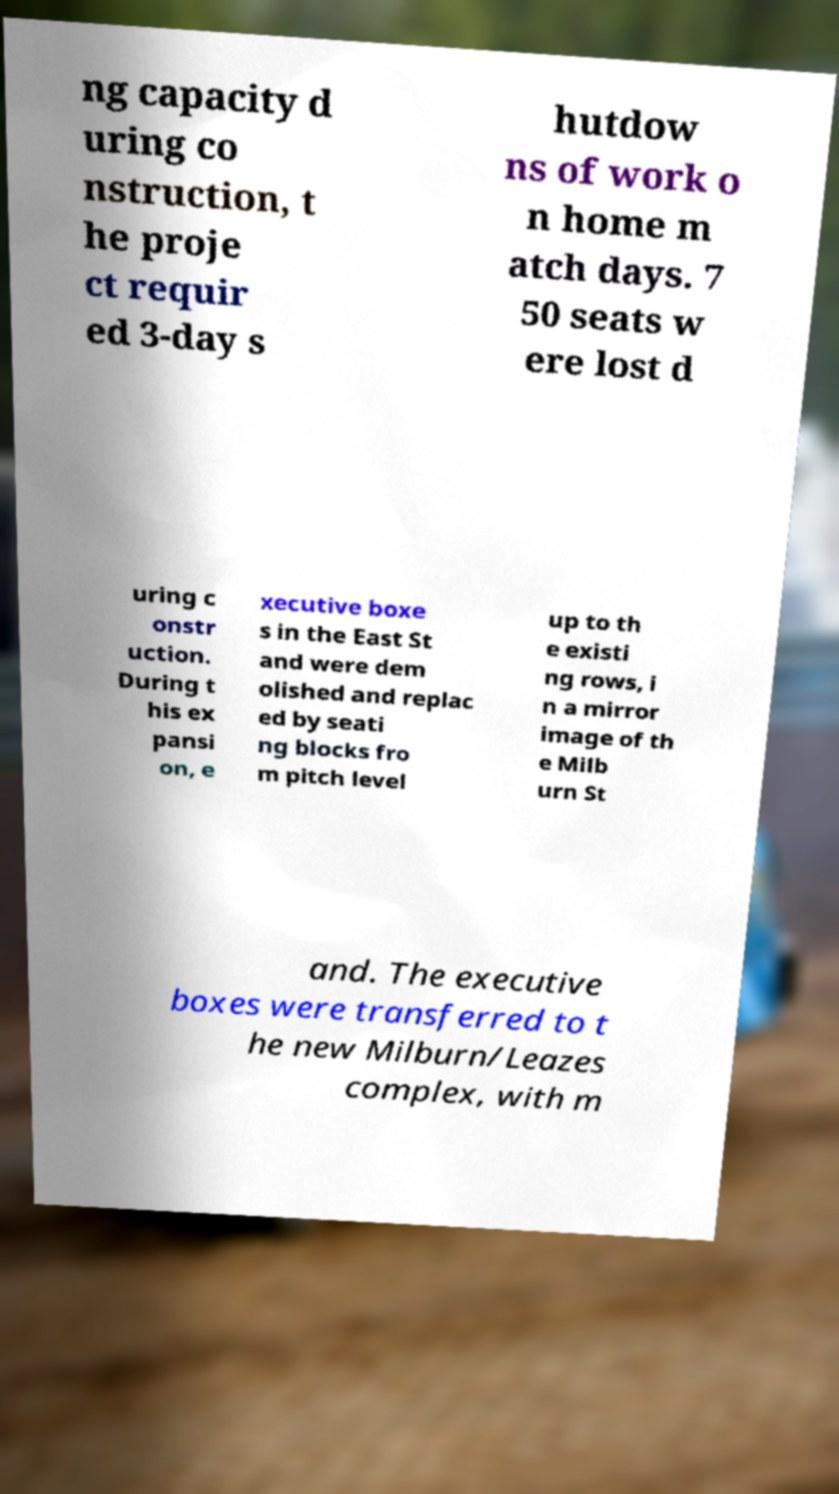Please read and relay the text visible in this image. What does it say? ng capacity d uring co nstruction, t he proje ct requir ed 3-day s hutdow ns of work o n home m atch days. 7 50 seats w ere lost d uring c onstr uction. During t his ex pansi on, e xecutive boxe s in the East St and were dem olished and replac ed by seati ng blocks fro m pitch level up to th e existi ng rows, i n a mirror image of th e Milb urn St and. The executive boxes were transferred to t he new Milburn/Leazes complex, with m 